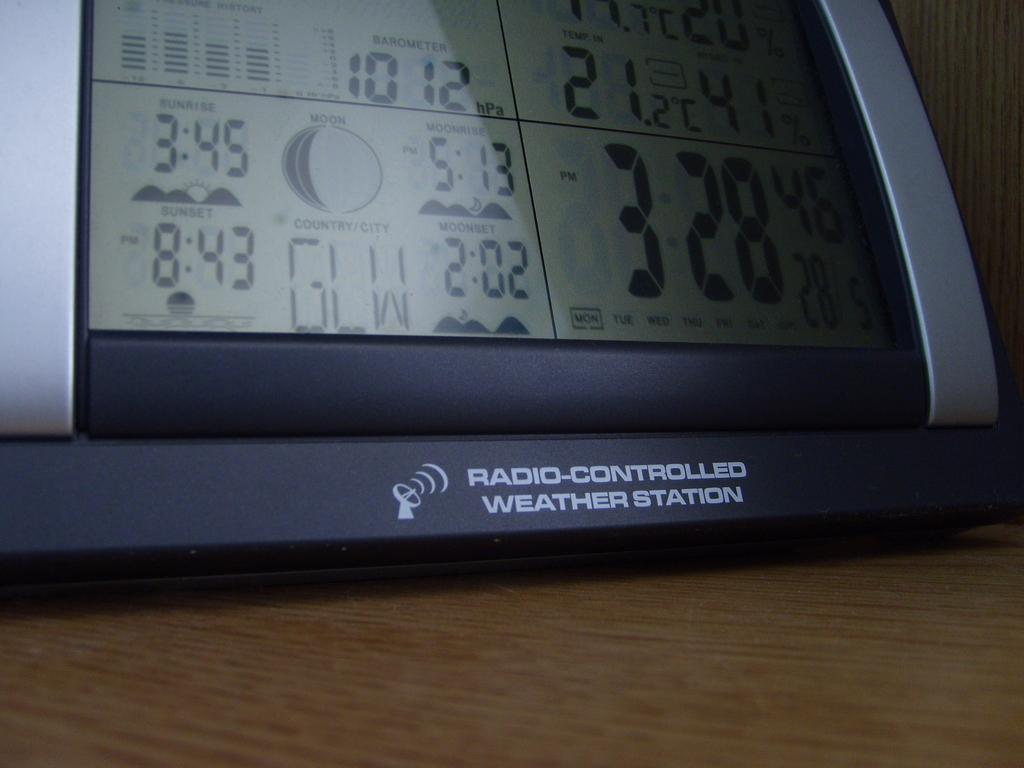<image>
Present a compact description of the photo's key features. An electronic clock that shows that sunset is at 8:43. 